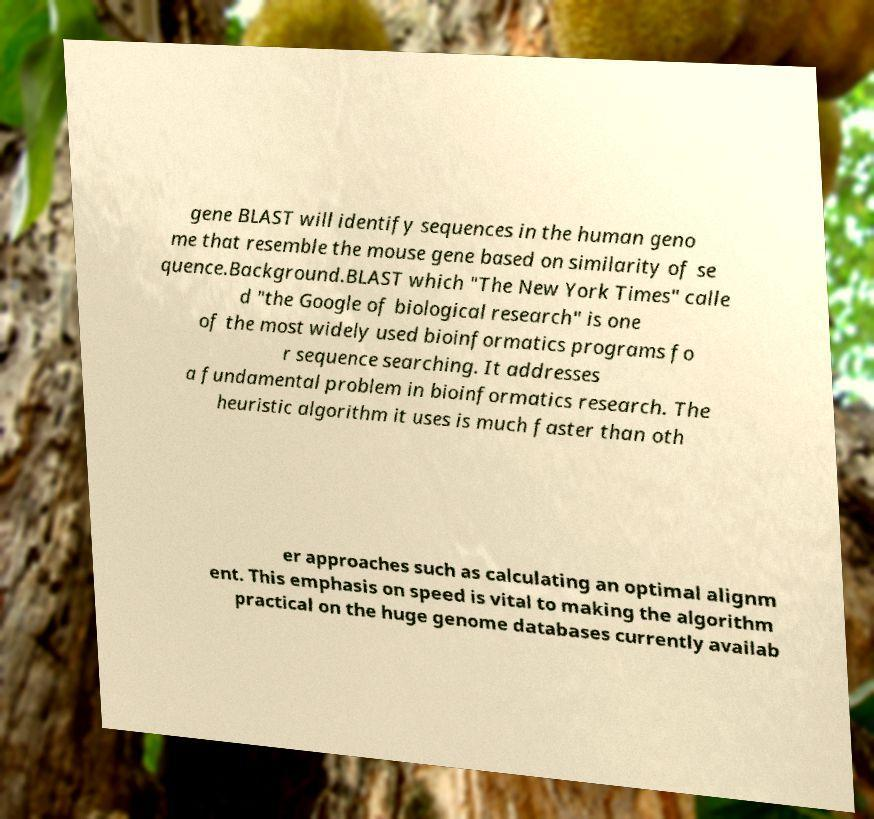Can you read and provide the text displayed in the image?This photo seems to have some interesting text. Can you extract and type it out for me? gene BLAST will identify sequences in the human geno me that resemble the mouse gene based on similarity of se quence.Background.BLAST which "The New York Times" calle d "the Google of biological research" is one of the most widely used bioinformatics programs fo r sequence searching. It addresses a fundamental problem in bioinformatics research. The heuristic algorithm it uses is much faster than oth er approaches such as calculating an optimal alignm ent. This emphasis on speed is vital to making the algorithm practical on the huge genome databases currently availab 